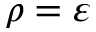<formula> <loc_0><loc_0><loc_500><loc_500>\rho = \varepsilon</formula> 